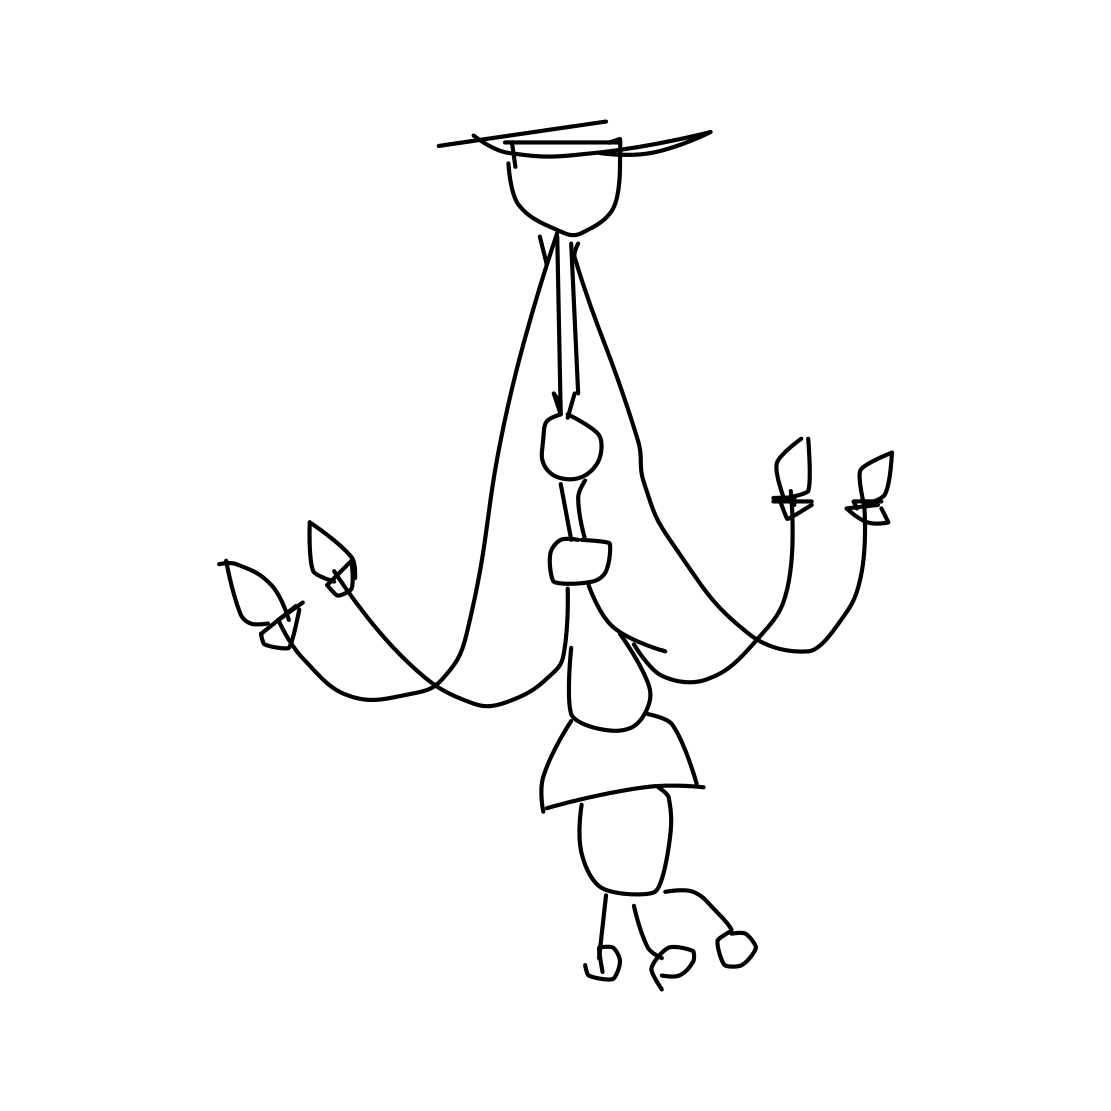Is there a sketchy diamond in the picture? No 